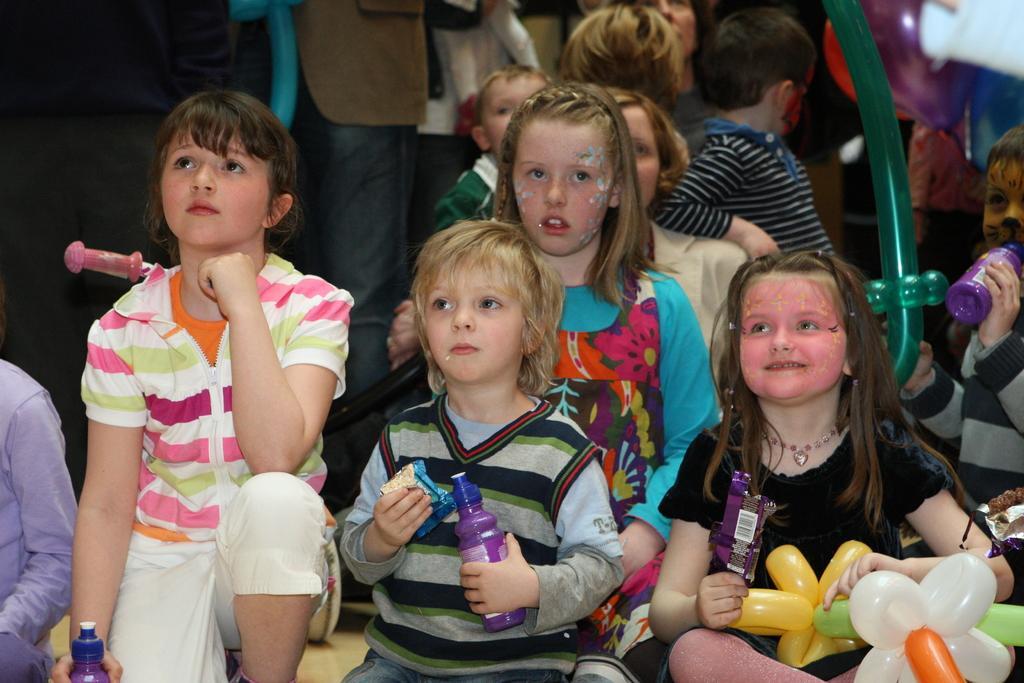Describe this image in one or two sentences. In this image I can see children and few of them are h holding bottles. I can also see smile on few faces. 